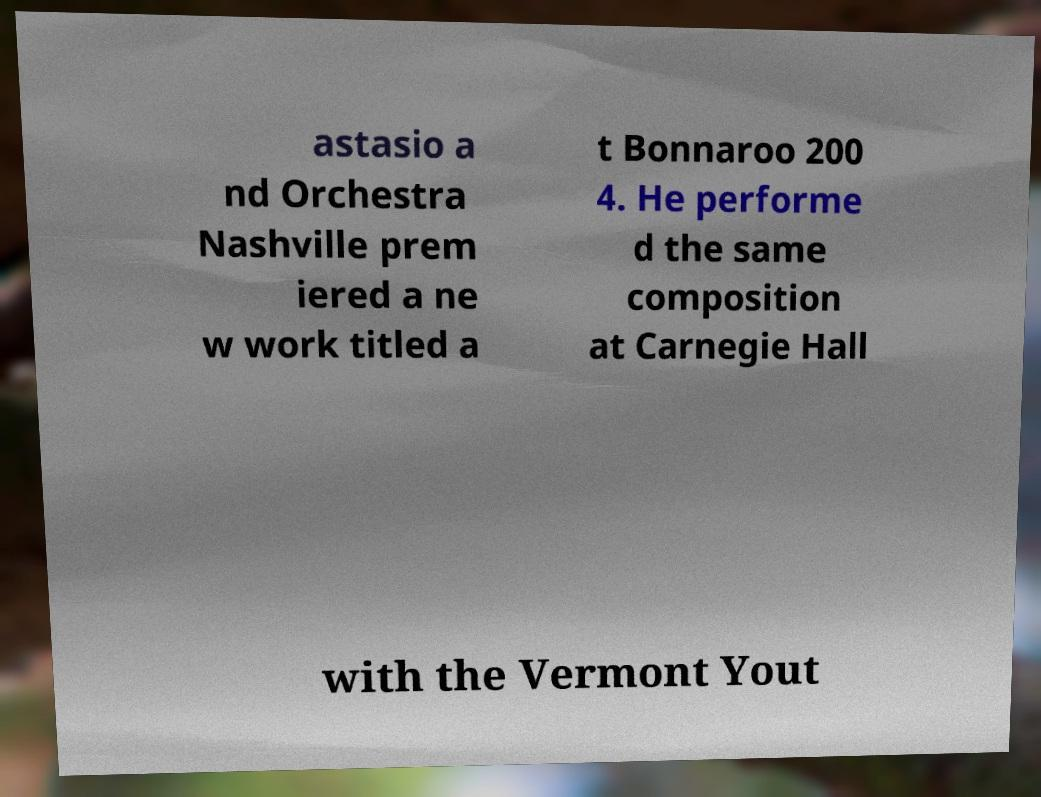Can you accurately transcribe the text from the provided image for me? astasio a nd Orchestra Nashville prem iered a ne w work titled a t Bonnaroo 200 4. He performe d the same composition at Carnegie Hall with the Vermont Yout 